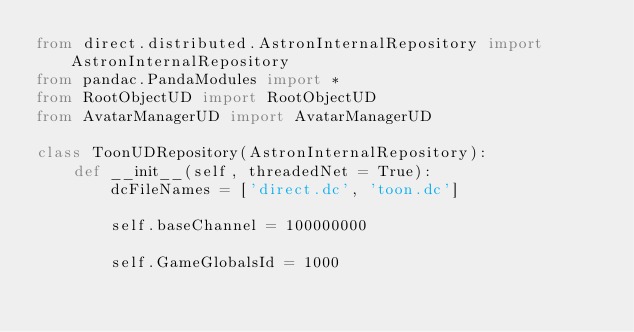Convert code to text. <code><loc_0><loc_0><loc_500><loc_500><_Python_>from direct.distributed.AstronInternalRepository import AstronInternalRepository
from pandac.PandaModules import *
from RootObjectUD import RootObjectUD
from AvatarManagerUD import AvatarManagerUD

class ToonUDRepository(AstronInternalRepository):
    def __init__(self, threadedNet = True):
        dcFileNames = ['direct.dc', 'toon.dc']

        self.baseChannel = 100000000

        self.GameGlobalsId = 1000
</code> 